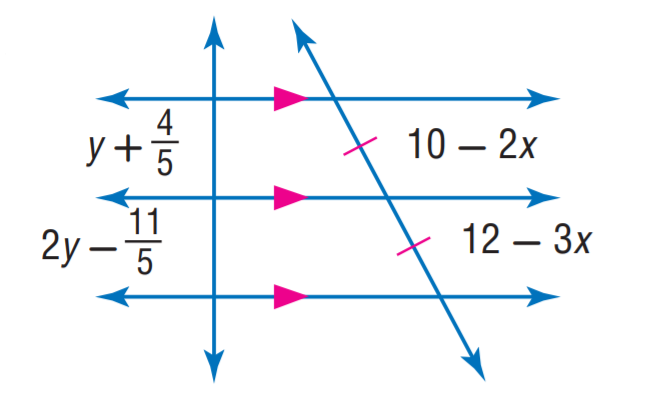Answer the mathemtical geometry problem and directly provide the correct option letter.
Question: Find x.
Choices: A: 1 B: 2 C: 3 D: 4 B 